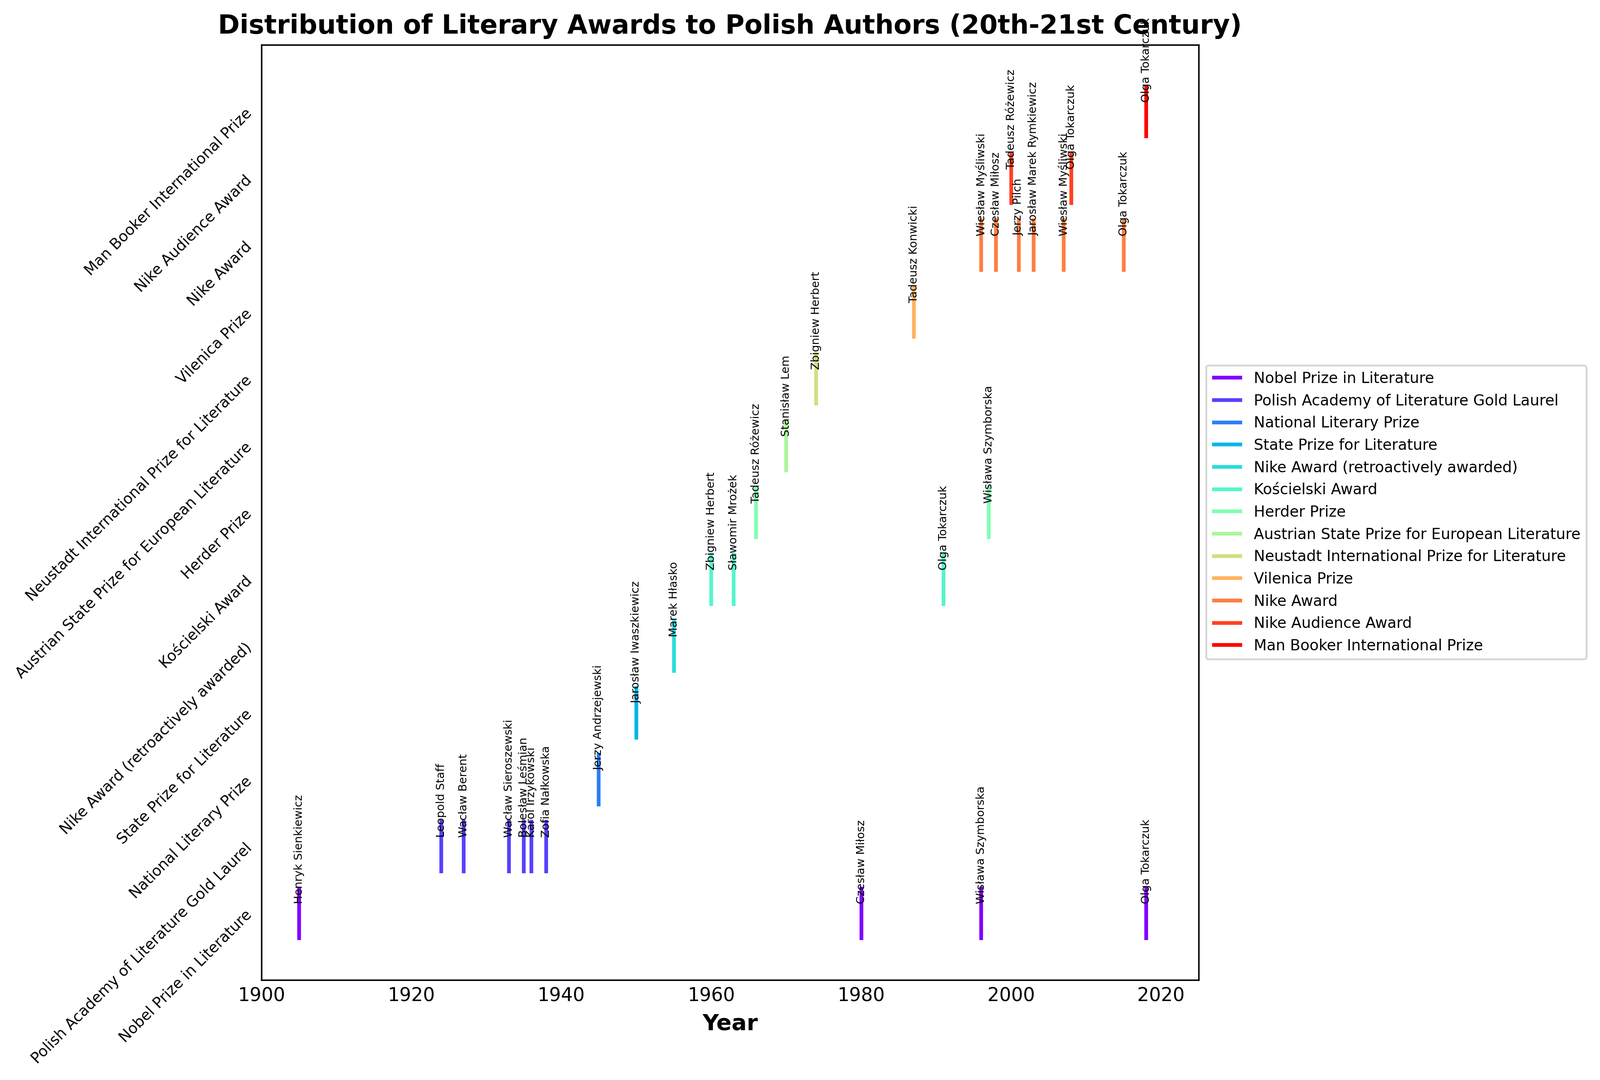Which author won the most different types of awards? By looking at the annotations on the plot, Olga Tokarczuk is an author who appears multiple times under different awards like the Kościelski Award, Nike Award, Man Booker International Prize, and Nobel Prize in Literature.
Answer: Olga Tokarczuk Between which years did the most significant increase in award diversity happen? To identify this, observe the plot to see the spread of awards over time. There is a noticeable increase in the diversity of awards roughly around the 1950s and 1960s.
Answer: 1950-1960 How many years after Henryk Sienkiewicz's Nobel Prize win did Czesław Miłosz earn his Nobel Prize? Henryk Sienkiewicz won the Nobel Prize in 1905, and Czesław Miłosz won it in 1980. The difference in years is 1980 - 1905.
Answer: 75 years Which literary award appears most frequently in the 21st century? By counting the number of awards from the plot in the 21st century (from 2001 onwards), the Nike Award appears most frequently.
Answer: Nike Award Did Zbigniew Herbert win the same award more than once? By observing Zbigniew Herbert's annotations, he won different awards: Kościelski Award in 1960 and Neustadt International Prize for Literature in 1974, but no repeated awards.
Answer: No Who received the Nike Award in 1998 and 2001? From annotations, Czesław Miłosz received the Nike Award in 1998 and Jerzy Pilch in 2001.
Answer: Czesław Miłosz and Jerzy Pilch Which period had the fewest awards given to Polish authors? Observing the plot over different periods, the era between 1900-1920 shows the least number of awards.
Answer: 1900-1920 What is the difference in years between Wisława Szymborska’s Herder Prize and her Nobel Prize? Wisława Szymborska won the Herder Prize in 1997 and the Nobel Prize in 1996. The difference is
Answer: -1 year 